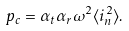Convert formula to latex. <formula><loc_0><loc_0><loc_500><loc_500>p _ { c } = \alpha _ { t } \alpha _ { r } \omega ^ { 2 } \langle i _ { n } ^ { 2 } \rangle .</formula> 